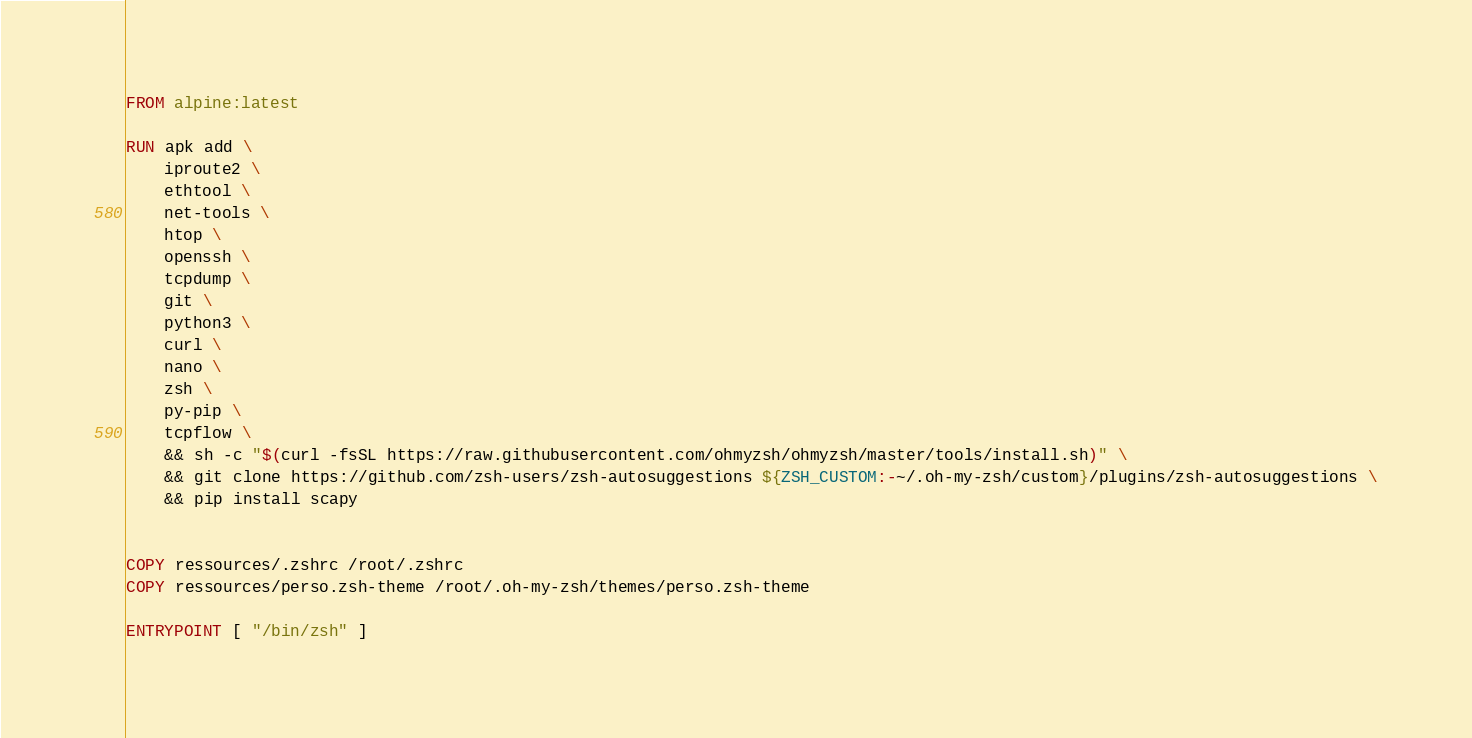Convert code to text. <code><loc_0><loc_0><loc_500><loc_500><_Dockerfile_>FROM alpine:latest

RUN apk add \
    iproute2 \
    ethtool \
    net-tools \
    htop \
    openssh \
    tcpdump \
    git \
    python3 \ 
    curl \
    nano \
    zsh \
    py-pip \
    tcpflow \
    && sh -c "$(curl -fsSL https://raw.githubusercontent.com/ohmyzsh/ohmyzsh/master/tools/install.sh)" \
    && git clone https://github.com/zsh-users/zsh-autosuggestions ${ZSH_CUSTOM:-~/.oh-my-zsh/custom}/plugins/zsh-autosuggestions \
    && pip install scapy


COPY ressources/.zshrc /root/.zshrc
COPY ressources/perso.zsh-theme /root/.oh-my-zsh/themes/perso.zsh-theme

ENTRYPOINT [ "/bin/zsh" ]



</code> 